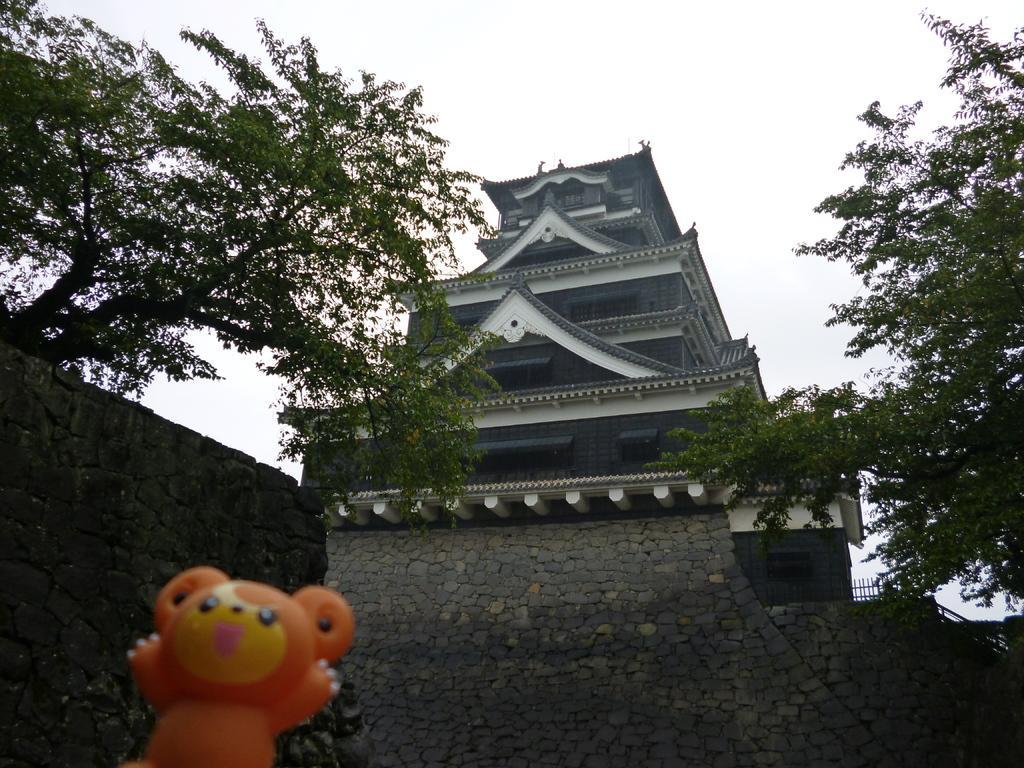Please provide a concise description of this image. In this image I can see a toy which is orange , yellow and black in color. In the background I can see a huge wall which is made up of rocks, few trees, a building which is blue and white in color and the sky. 